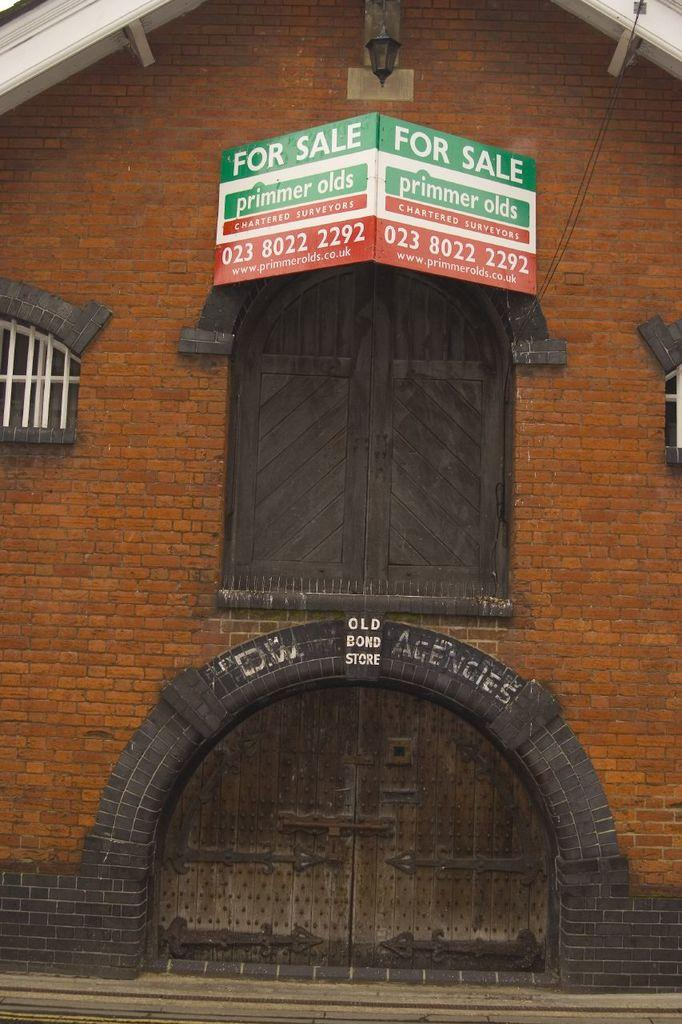What type of openings can be seen in the image? There are doors and windows in the image. What other object can be seen in the image? There is a board in the image. What might provide illumination in the image? There is a light in the image. What color is the cloth draped over the board in the image? There is no cloth draped over the board in the image. What type of sweater is the person wearing in the image? There is no person or sweater present in the image. 